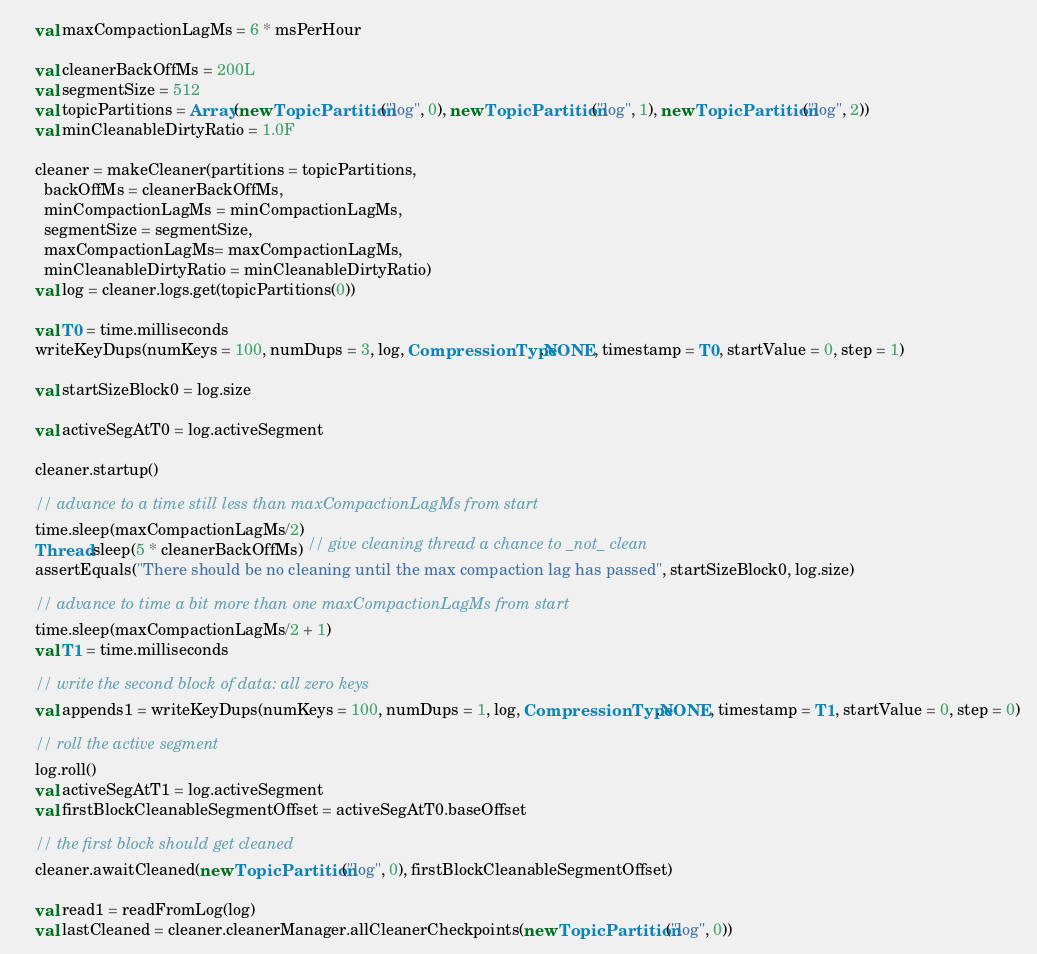Convert code to text. <code><loc_0><loc_0><loc_500><loc_500><_Scala_>    val maxCompactionLagMs = 6 * msPerHour

    val cleanerBackOffMs = 200L
    val segmentSize = 512
    val topicPartitions = Array(new TopicPartition("log", 0), new TopicPartition("log", 1), new TopicPartition("log", 2))
    val minCleanableDirtyRatio = 1.0F

    cleaner = makeCleaner(partitions = topicPartitions,
      backOffMs = cleanerBackOffMs,
      minCompactionLagMs = minCompactionLagMs,
      segmentSize = segmentSize,
      maxCompactionLagMs= maxCompactionLagMs,
      minCleanableDirtyRatio = minCleanableDirtyRatio)
    val log = cleaner.logs.get(topicPartitions(0))

    val T0 = time.milliseconds
    writeKeyDups(numKeys = 100, numDups = 3, log, CompressionType.NONE, timestamp = T0, startValue = 0, step = 1)

    val startSizeBlock0 = log.size

    val activeSegAtT0 = log.activeSegment

    cleaner.startup()

    // advance to a time still less than maxCompactionLagMs from start
    time.sleep(maxCompactionLagMs/2)
    Thread.sleep(5 * cleanerBackOffMs) // give cleaning thread a chance to _not_ clean
    assertEquals("There should be no cleaning until the max compaction lag has passed", startSizeBlock0, log.size)

    // advance to time a bit more than one maxCompactionLagMs from start
    time.sleep(maxCompactionLagMs/2 + 1)
    val T1 = time.milliseconds

    // write the second block of data: all zero keys
    val appends1 = writeKeyDups(numKeys = 100, numDups = 1, log, CompressionType.NONE, timestamp = T1, startValue = 0, step = 0)

    // roll the active segment
    log.roll()
    val activeSegAtT1 = log.activeSegment
    val firstBlockCleanableSegmentOffset = activeSegAtT0.baseOffset

    // the first block should get cleaned
    cleaner.awaitCleaned(new TopicPartition("log", 0), firstBlockCleanableSegmentOffset)

    val read1 = readFromLog(log)
    val lastCleaned = cleaner.cleanerManager.allCleanerCheckpoints(new TopicPartition("log", 0))</code> 